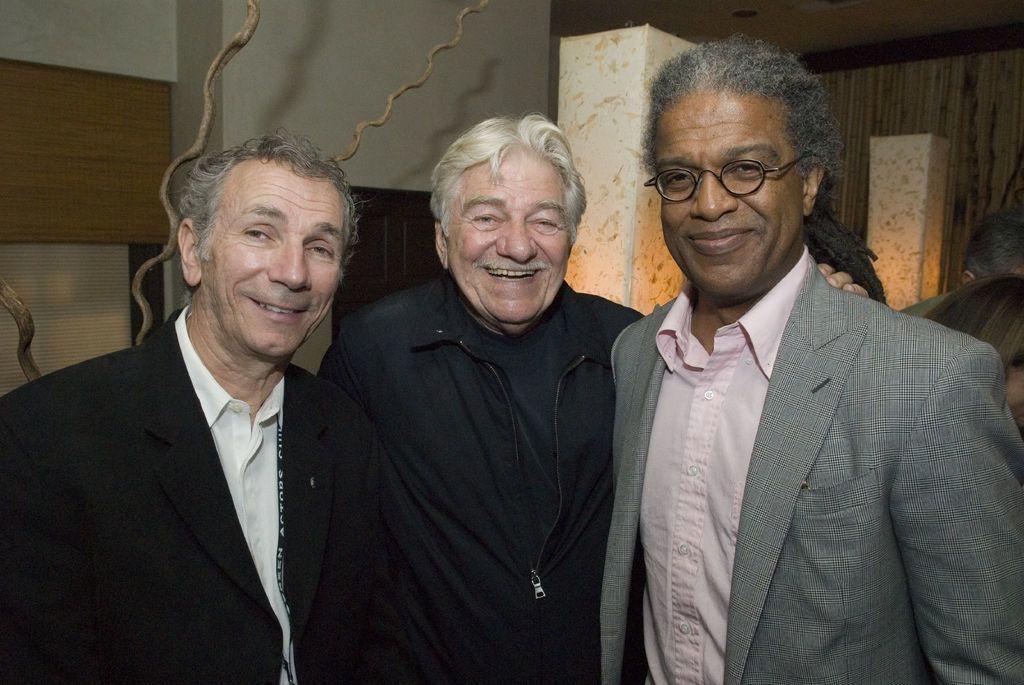Can you describe this image briefly? In front of the picture, we see three men are standing. Three of them are smiling and they are posing for the photo. The man on the right side is wearing the spectacles. Behind them, we see a white wall and white pillars. On the left side, we see a wooden board. In the background, we see a curtain. 